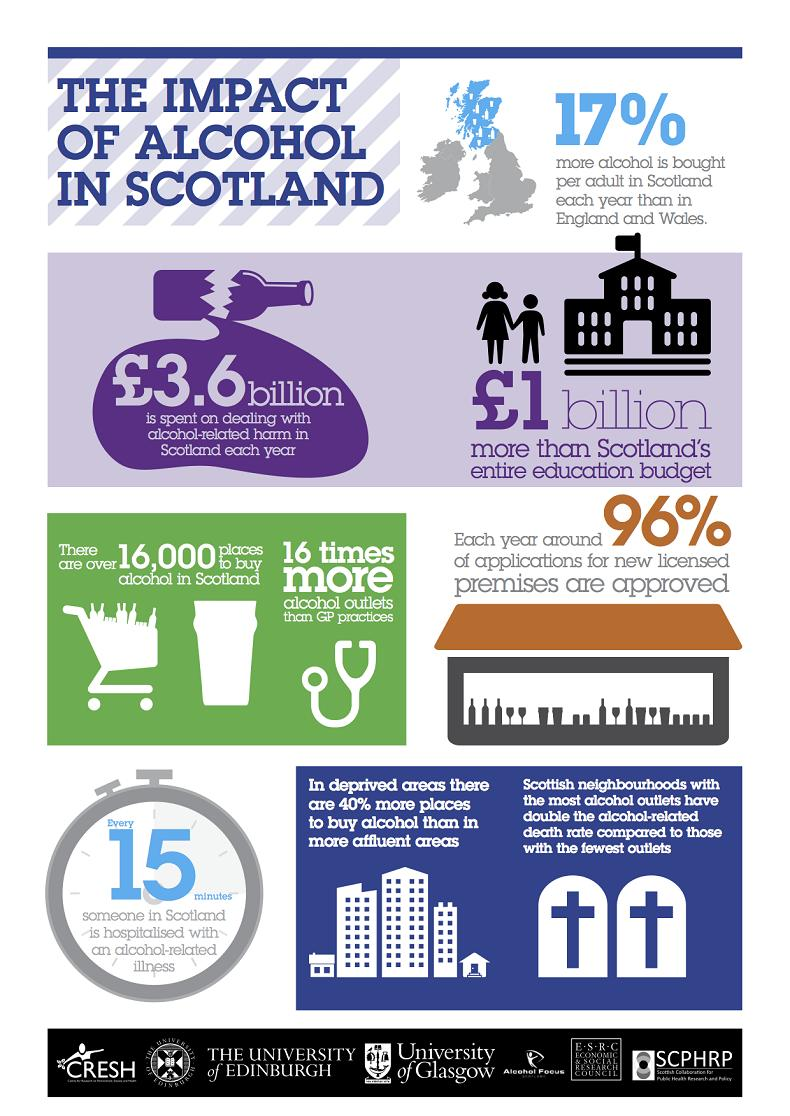Mention a couple of crucial points in this snapshot. The color of the broken bottle is violet. There are two crosses present in this infographic. There are approximately 16,000 retail outlets in Scotland where alcohol can be purchased. There are 6 buildings depicted in this infographic. 